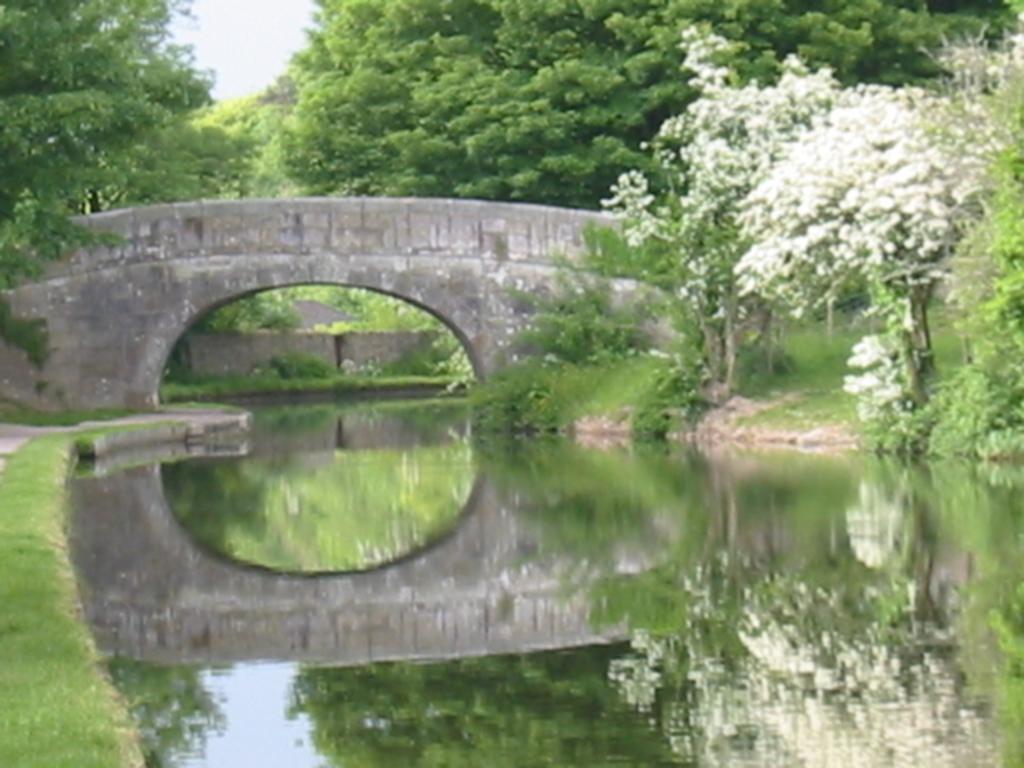Can you describe this image briefly? In this image I can see the water. To the right I can see the white color flowers to the trees. In the background I can see the bridge, many trees and the sky. 